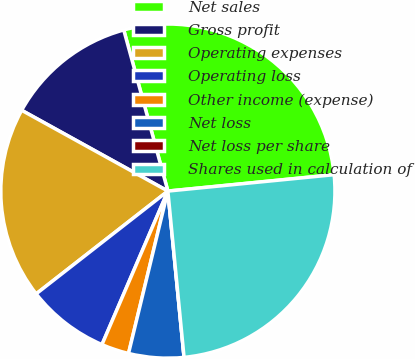<chart> <loc_0><loc_0><loc_500><loc_500><pie_chart><fcel>Net sales<fcel>Gross profit<fcel>Operating expenses<fcel>Operating loss<fcel>Other income (expense)<fcel>Net loss<fcel>Net loss per share<fcel>Shares used in calculation of<nl><fcel>27.69%<fcel>12.71%<fcel>18.58%<fcel>8.0%<fcel>2.67%<fcel>5.33%<fcel>0.0%<fcel>25.02%<nl></chart> 